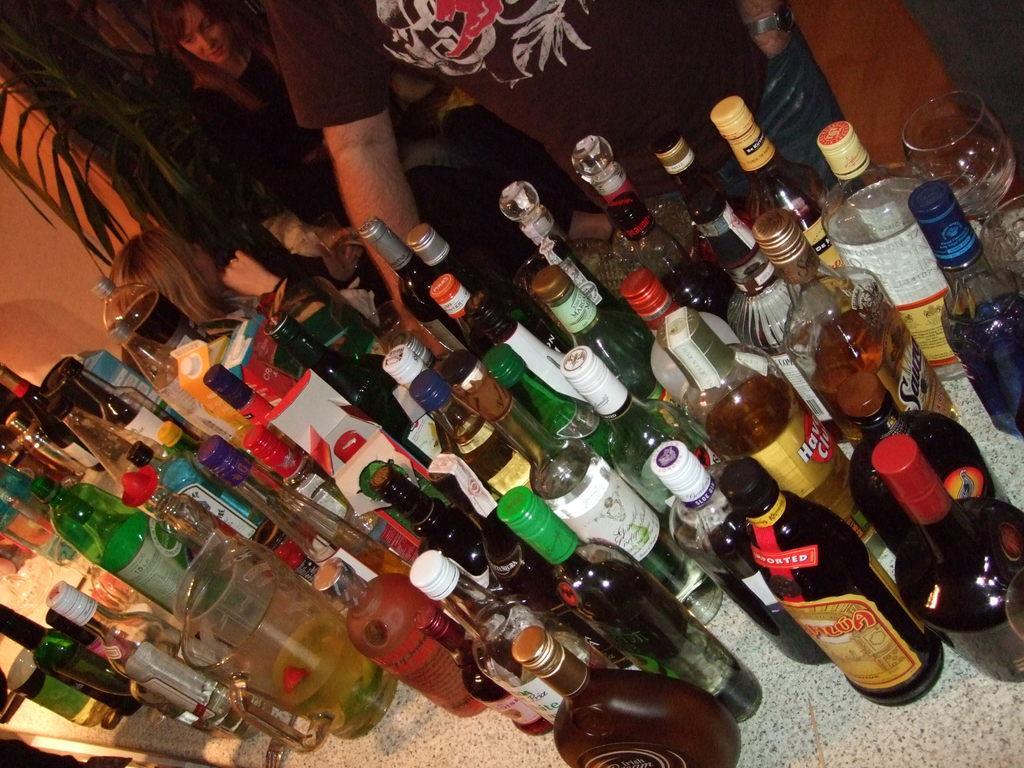Can you describe this image briefly? on a table there are many glass bottles, glasses and a jug. the glass bottles are of different colors such as black, transparent, green, brown, blue. at the right back there are people standing. a person is wearing a brown t shirt and at the back a person is sitting. behind them there is a plant. 